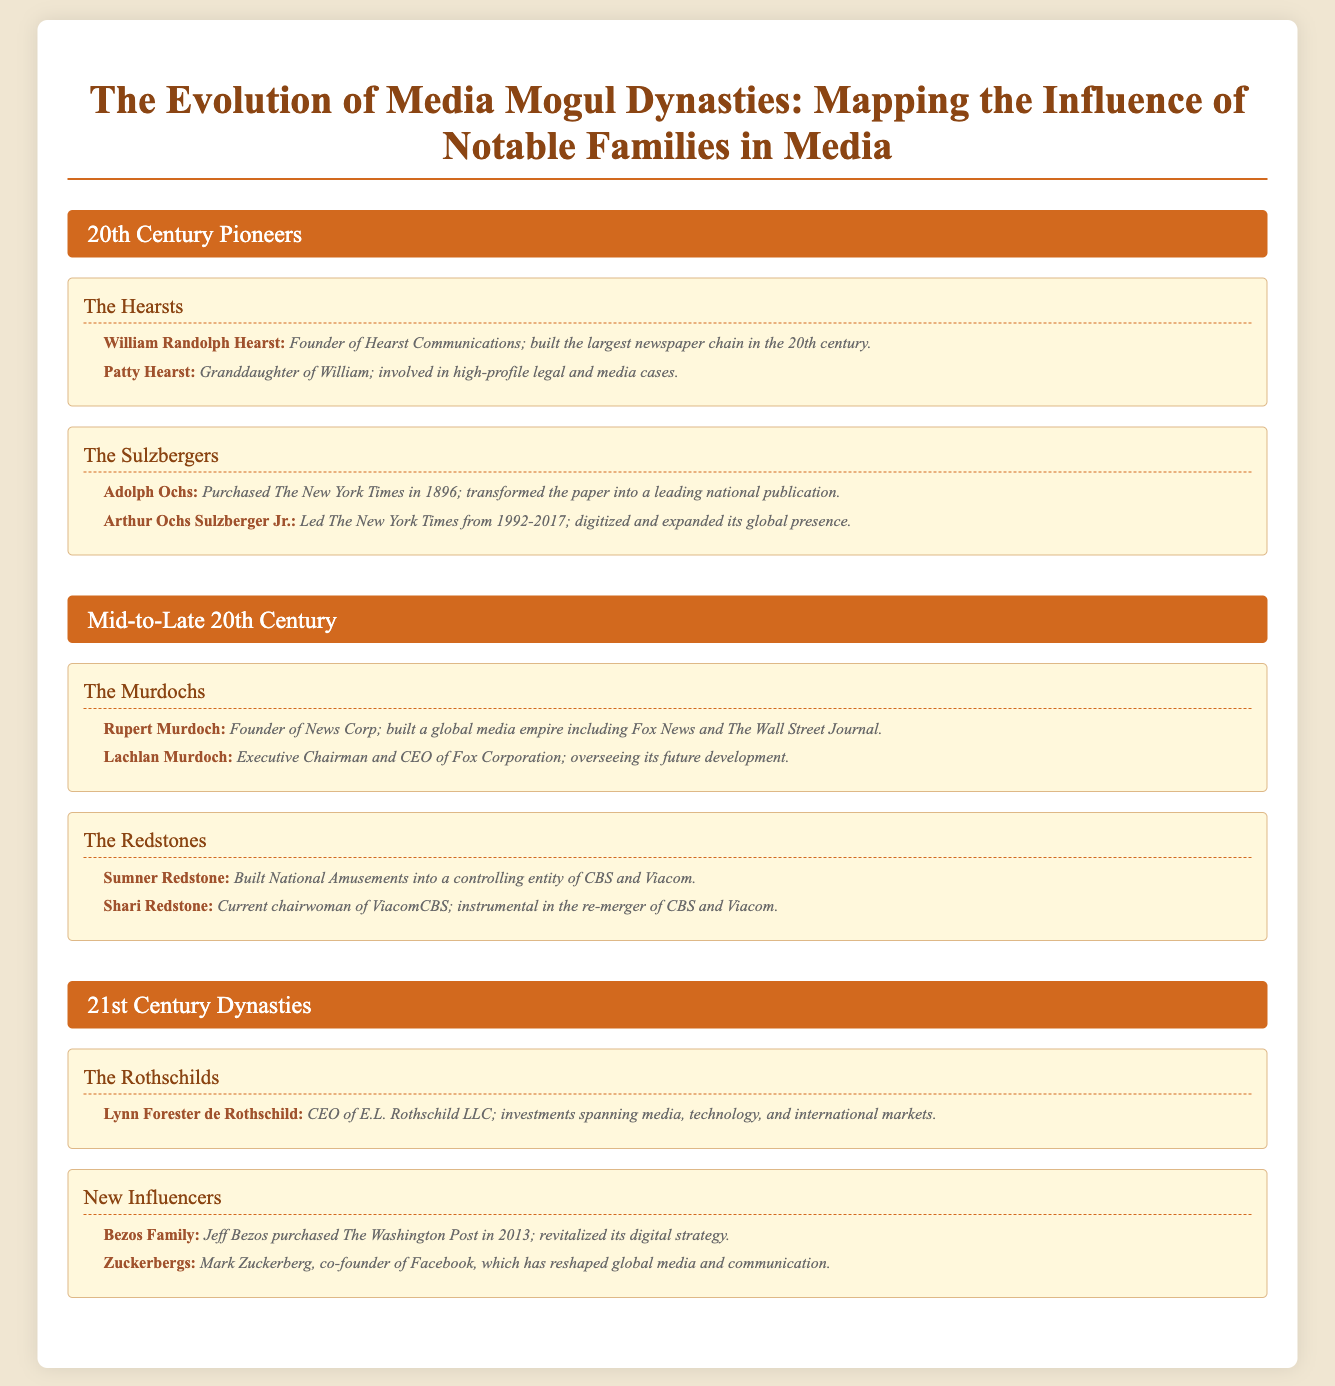What family is associated with The New York Times? The document states that the Sulzbergers are the family associated with The New York Times.
Answer: The Sulzbergers Who founded Hearst Communications? It is noted in the document that William Randolph Hearst founded Hearst Communications.
Answer: William Randolph Hearst Which family is linked to the creation of Fox News? According to the document, the Murdoch family is linked to the creation of Fox News.
Answer: The Murdochs What year did Jeff Bezos purchase The Washington Post? The document mentions that Jeff Bezos purchased The Washington Post in the year 2013.
Answer: 2013 Who is the CEO of E.L. Rothschild LLC? The document states that Lynn Forester de Rothschild is the CEO of E.L. Rothschild LLC.
Answer: Lynn Forester de Rothschild What media dynasty underwent a re-merger involving CBS and Viacom? The Redstone family is highlighted in the document for being involved in the re-merger of CBS and Viacom.
Answer: The Redstones Which member of the Zuckerberg family is mentioned in the document? It indicates that Mark Zuckerberg is the member of the Zuckerberg family mentioned in the document.
Answer: Mark Zuckerberg What distinguishes the 21st Century Dynasties section? This section includes new influencers in the media landscape, presenting modern families like the Bezoses and Zuckerbergs.
Answer: New Influencers 